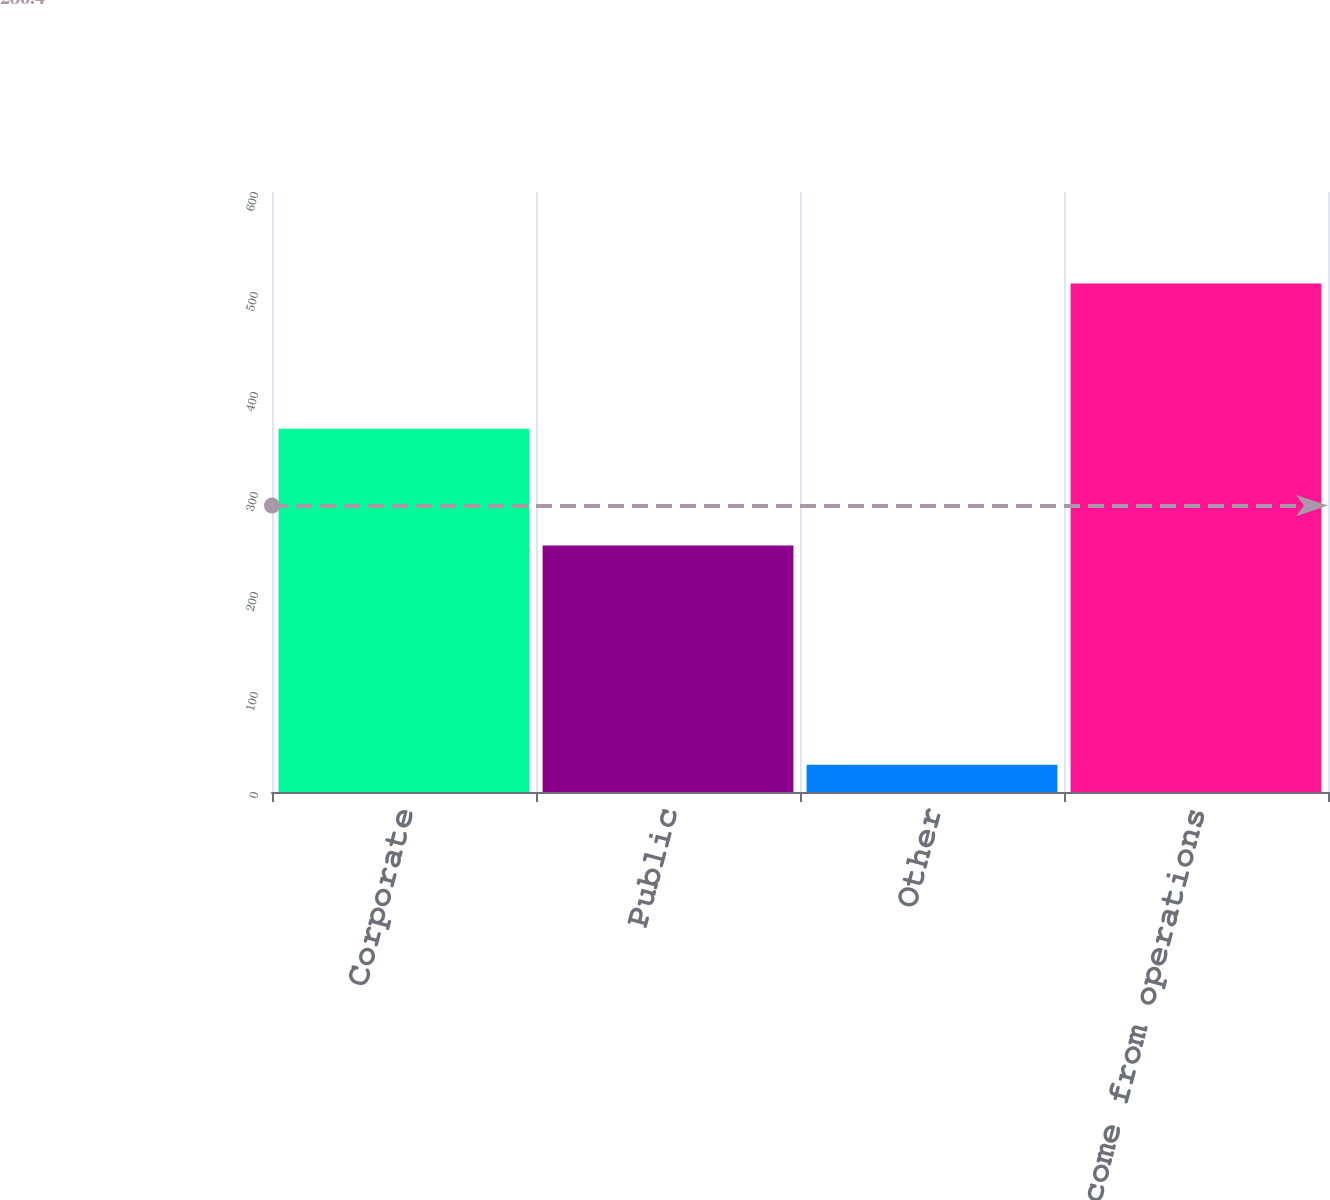<chart> <loc_0><loc_0><loc_500><loc_500><bar_chart><fcel>Corporate<fcel>Public<fcel>Other<fcel>Total income from operations<nl><fcel>363.3<fcel>246.5<fcel>27.2<fcel>508.6<nl></chart> 